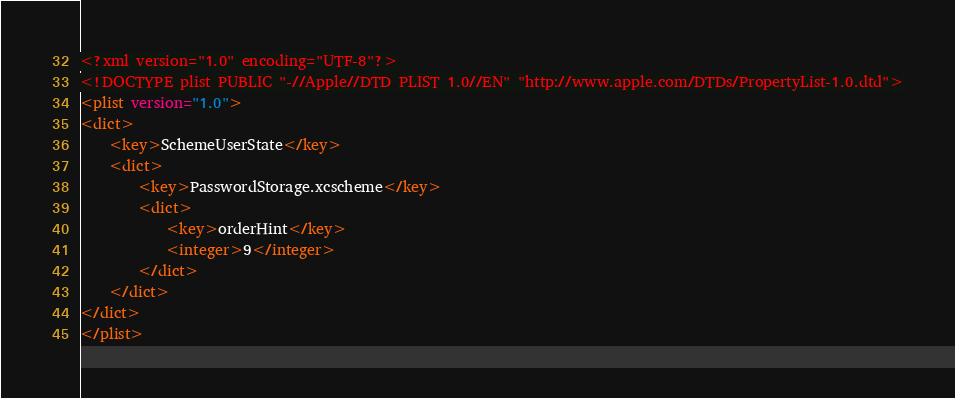<code> <loc_0><loc_0><loc_500><loc_500><_XML_><?xml version="1.0" encoding="UTF-8"?>
<!DOCTYPE plist PUBLIC "-//Apple//DTD PLIST 1.0//EN" "http://www.apple.com/DTDs/PropertyList-1.0.dtd">
<plist version="1.0">
<dict>
	<key>SchemeUserState</key>
	<dict>
		<key>PasswordStorage.xcscheme</key>
		<dict>
			<key>orderHint</key>
			<integer>9</integer>
		</dict>
	</dict>
</dict>
</plist>
</code> 